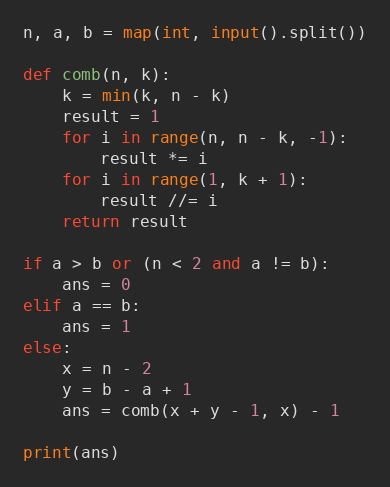<code> <loc_0><loc_0><loc_500><loc_500><_Python_>n, a, b = map(int, input().split())

def comb(n, k):
    k = min(k, n - k)
    result = 1
    for i in range(n, n - k, -1):
        result *= i
    for i in range(1, k + 1):
        result //= i 
    return result

if a > b or (n < 2 and a != b):
    ans = 0
elif a == b:
    ans = 1
else:
    x = n - 2
    y = b - a + 1
    ans = comb(x + y - 1, x) - 1
    
print(ans)</code> 